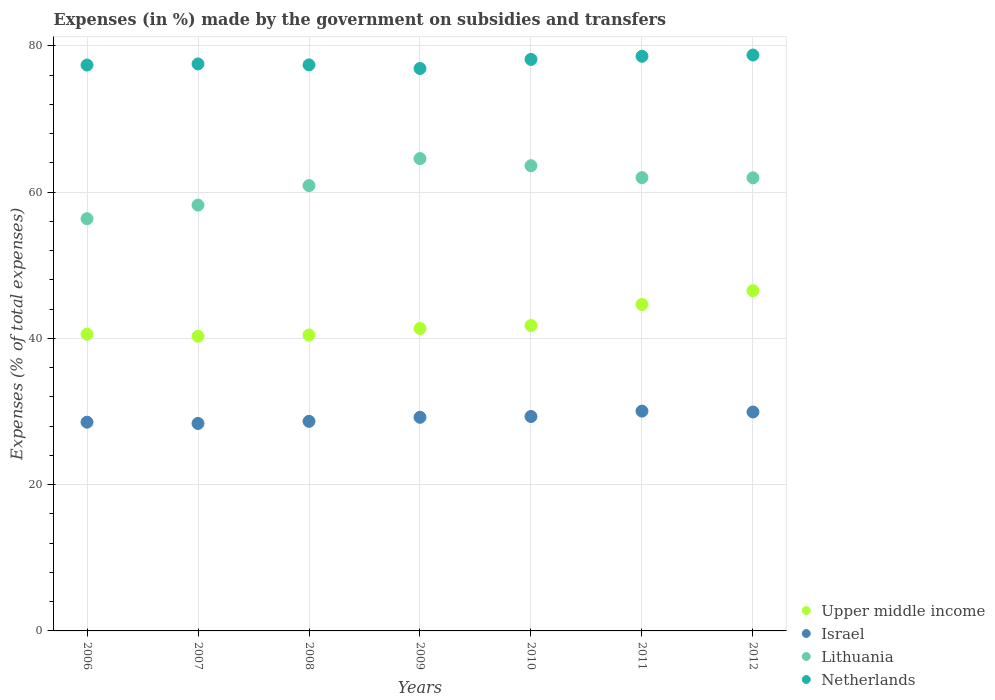What is the percentage of expenses made by the government on subsidies and transfers in Israel in 2008?
Provide a short and direct response. 28.66. Across all years, what is the maximum percentage of expenses made by the government on subsidies and transfers in Netherlands?
Make the answer very short. 78.76. Across all years, what is the minimum percentage of expenses made by the government on subsidies and transfers in Netherlands?
Make the answer very short. 76.91. What is the total percentage of expenses made by the government on subsidies and transfers in Upper middle income in the graph?
Provide a short and direct response. 295.63. What is the difference between the percentage of expenses made by the government on subsidies and transfers in Upper middle income in 2008 and that in 2010?
Keep it short and to the point. -1.3. What is the difference between the percentage of expenses made by the government on subsidies and transfers in Israel in 2009 and the percentage of expenses made by the government on subsidies and transfers in Netherlands in 2007?
Your response must be concise. -48.32. What is the average percentage of expenses made by the government on subsidies and transfers in Netherlands per year?
Offer a terse response. 77.82. In the year 2009, what is the difference between the percentage of expenses made by the government on subsidies and transfers in Netherlands and percentage of expenses made by the government on subsidies and transfers in Upper middle income?
Keep it short and to the point. 35.56. In how many years, is the percentage of expenses made by the government on subsidies and transfers in Upper middle income greater than 44 %?
Make the answer very short. 2. What is the ratio of the percentage of expenses made by the government on subsidies and transfers in Israel in 2008 to that in 2009?
Your answer should be compact. 0.98. Is the percentage of expenses made by the government on subsidies and transfers in Israel in 2008 less than that in 2010?
Make the answer very short. Yes. What is the difference between the highest and the second highest percentage of expenses made by the government on subsidies and transfers in Upper middle income?
Your response must be concise. 1.89. What is the difference between the highest and the lowest percentage of expenses made by the government on subsidies and transfers in Lithuania?
Your answer should be compact. 8.22. In how many years, is the percentage of expenses made by the government on subsidies and transfers in Israel greater than the average percentage of expenses made by the government on subsidies and transfers in Israel taken over all years?
Provide a short and direct response. 4. Is it the case that in every year, the sum of the percentage of expenses made by the government on subsidies and transfers in Netherlands and percentage of expenses made by the government on subsidies and transfers in Lithuania  is greater than the sum of percentage of expenses made by the government on subsidies and transfers in Israel and percentage of expenses made by the government on subsidies and transfers in Upper middle income?
Your answer should be very brief. Yes. Is the percentage of expenses made by the government on subsidies and transfers in Lithuania strictly greater than the percentage of expenses made by the government on subsidies and transfers in Netherlands over the years?
Give a very brief answer. No. How many dotlines are there?
Offer a terse response. 4. Are the values on the major ticks of Y-axis written in scientific E-notation?
Keep it short and to the point. No. Does the graph contain grids?
Keep it short and to the point. Yes. How are the legend labels stacked?
Your response must be concise. Vertical. What is the title of the graph?
Offer a terse response. Expenses (in %) made by the government on subsidies and transfers. Does "Guam" appear as one of the legend labels in the graph?
Provide a succinct answer. No. What is the label or title of the Y-axis?
Your answer should be very brief. Expenses (% of total expenses). What is the Expenses (% of total expenses) of Upper middle income in 2006?
Ensure brevity in your answer.  40.58. What is the Expenses (% of total expenses) in Israel in 2006?
Give a very brief answer. 28.55. What is the Expenses (% of total expenses) in Lithuania in 2006?
Ensure brevity in your answer.  56.37. What is the Expenses (% of total expenses) of Netherlands in 2006?
Offer a terse response. 77.38. What is the Expenses (% of total expenses) of Upper middle income in 2007?
Offer a terse response. 40.3. What is the Expenses (% of total expenses) in Israel in 2007?
Ensure brevity in your answer.  28.37. What is the Expenses (% of total expenses) in Lithuania in 2007?
Ensure brevity in your answer.  58.23. What is the Expenses (% of total expenses) in Netherlands in 2007?
Your answer should be compact. 77.54. What is the Expenses (% of total expenses) in Upper middle income in 2008?
Offer a very short reply. 40.47. What is the Expenses (% of total expenses) of Israel in 2008?
Offer a terse response. 28.66. What is the Expenses (% of total expenses) in Lithuania in 2008?
Your response must be concise. 60.9. What is the Expenses (% of total expenses) in Netherlands in 2008?
Your response must be concise. 77.41. What is the Expenses (% of total expenses) of Upper middle income in 2009?
Provide a short and direct response. 41.36. What is the Expenses (% of total expenses) of Israel in 2009?
Ensure brevity in your answer.  29.21. What is the Expenses (% of total expenses) of Lithuania in 2009?
Your response must be concise. 64.59. What is the Expenses (% of total expenses) in Netherlands in 2009?
Your answer should be very brief. 76.91. What is the Expenses (% of total expenses) in Upper middle income in 2010?
Keep it short and to the point. 41.76. What is the Expenses (% of total expenses) in Israel in 2010?
Give a very brief answer. 29.32. What is the Expenses (% of total expenses) in Lithuania in 2010?
Provide a succinct answer. 63.62. What is the Expenses (% of total expenses) of Netherlands in 2010?
Your response must be concise. 78.16. What is the Expenses (% of total expenses) of Upper middle income in 2011?
Give a very brief answer. 44.64. What is the Expenses (% of total expenses) in Israel in 2011?
Ensure brevity in your answer.  30.06. What is the Expenses (% of total expenses) in Lithuania in 2011?
Provide a succinct answer. 61.99. What is the Expenses (% of total expenses) in Netherlands in 2011?
Your answer should be compact. 78.58. What is the Expenses (% of total expenses) in Upper middle income in 2012?
Offer a very short reply. 46.53. What is the Expenses (% of total expenses) in Israel in 2012?
Keep it short and to the point. 29.94. What is the Expenses (% of total expenses) in Lithuania in 2012?
Offer a very short reply. 61.96. What is the Expenses (% of total expenses) in Netherlands in 2012?
Make the answer very short. 78.76. Across all years, what is the maximum Expenses (% of total expenses) in Upper middle income?
Offer a terse response. 46.53. Across all years, what is the maximum Expenses (% of total expenses) in Israel?
Offer a very short reply. 30.06. Across all years, what is the maximum Expenses (% of total expenses) of Lithuania?
Ensure brevity in your answer.  64.59. Across all years, what is the maximum Expenses (% of total expenses) in Netherlands?
Provide a succinct answer. 78.76. Across all years, what is the minimum Expenses (% of total expenses) in Upper middle income?
Your response must be concise. 40.3. Across all years, what is the minimum Expenses (% of total expenses) of Israel?
Your answer should be very brief. 28.37. Across all years, what is the minimum Expenses (% of total expenses) in Lithuania?
Make the answer very short. 56.37. Across all years, what is the minimum Expenses (% of total expenses) in Netherlands?
Give a very brief answer. 76.91. What is the total Expenses (% of total expenses) in Upper middle income in the graph?
Give a very brief answer. 295.63. What is the total Expenses (% of total expenses) in Israel in the graph?
Your answer should be compact. 204.11. What is the total Expenses (% of total expenses) of Lithuania in the graph?
Keep it short and to the point. 427.66. What is the total Expenses (% of total expenses) in Netherlands in the graph?
Ensure brevity in your answer.  544.74. What is the difference between the Expenses (% of total expenses) of Upper middle income in 2006 and that in 2007?
Provide a succinct answer. 0.28. What is the difference between the Expenses (% of total expenses) in Israel in 2006 and that in 2007?
Offer a very short reply. 0.17. What is the difference between the Expenses (% of total expenses) in Lithuania in 2006 and that in 2007?
Keep it short and to the point. -1.86. What is the difference between the Expenses (% of total expenses) of Netherlands in 2006 and that in 2007?
Keep it short and to the point. -0.15. What is the difference between the Expenses (% of total expenses) of Upper middle income in 2006 and that in 2008?
Provide a short and direct response. 0.11. What is the difference between the Expenses (% of total expenses) of Israel in 2006 and that in 2008?
Your answer should be compact. -0.11. What is the difference between the Expenses (% of total expenses) in Lithuania in 2006 and that in 2008?
Offer a terse response. -4.53. What is the difference between the Expenses (% of total expenses) in Netherlands in 2006 and that in 2008?
Give a very brief answer. -0.02. What is the difference between the Expenses (% of total expenses) of Upper middle income in 2006 and that in 2009?
Ensure brevity in your answer.  -0.78. What is the difference between the Expenses (% of total expenses) in Israel in 2006 and that in 2009?
Offer a very short reply. -0.67. What is the difference between the Expenses (% of total expenses) in Lithuania in 2006 and that in 2009?
Make the answer very short. -8.22. What is the difference between the Expenses (% of total expenses) in Netherlands in 2006 and that in 2009?
Give a very brief answer. 0.47. What is the difference between the Expenses (% of total expenses) of Upper middle income in 2006 and that in 2010?
Make the answer very short. -1.19. What is the difference between the Expenses (% of total expenses) of Israel in 2006 and that in 2010?
Make the answer very short. -0.78. What is the difference between the Expenses (% of total expenses) of Lithuania in 2006 and that in 2010?
Make the answer very short. -7.25. What is the difference between the Expenses (% of total expenses) in Netherlands in 2006 and that in 2010?
Your answer should be compact. -0.77. What is the difference between the Expenses (% of total expenses) in Upper middle income in 2006 and that in 2011?
Your answer should be compact. -4.06. What is the difference between the Expenses (% of total expenses) of Israel in 2006 and that in 2011?
Give a very brief answer. -1.51. What is the difference between the Expenses (% of total expenses) of Lithuania in 2006 and that in 2011?
Your answer should be compact. -5.62. What is the difference between the Expenses (% of total expenses) of Netherlands in 2006 and that in 2011?
Your response must be concise. -1.2. What is the difference between the Expenses (% of total expenses) in Upper middle income in 2006 and that in 2012?
Make the answer very short. -5.95. What is the difference between the Expenses (% of total expenses) in Israel in 2006 and that in 2012?
Your response must be concise. -1.39. What is the difference between the Expenses (% of total expenses) of Lithuania in 2006 and that in 2012?
Ensure brevity in your answer.  -5.59. What is the difference between the Expenses (% of total expenses) of Netherlands in 2006 and that in 2012?
Make the answer very short. -1.37. What is the difference between the Expenses (% of total expenses) of Upper middle income in 2007 and that in 2008?
Your answer should be compact. -0.17. What is the difference between the Expenses (% of total expenses) of Israel in 2007 and that in 2008?
Make the answer very short. -0.29. What is the difference between the Expenses (% of total expenses) of Lithuania in 2007 and that in 2008?
Your answer should be very brief. -2.67. What is the difference between the Expenses (% of total expenses) in Netherlands in 2007 and that in 2008?
Your response must be concise. 0.13. What is the difference between the Expenses (% of total expenses) of Upper middle income in 2007 and that in 2009?
Ensure brevity in your answer.  -1.06. What is the difference between the Expenses (% of total expenses) of Israel in 2007 and that in 2009?
Keep it short and to the point. -0.84. What is the difference between the Expenses (% of total expenses) of Lithuania in 2007 and that in 2009?
Provide a short and direct response. -6.36. What is the difference between the Expenses (% of total expenses) in Netherlands in 2007 and that in 2009?
Keep it short and to the point. 0.63. What is the difference between the Expenses (% of total expenses) in Upper middle income in 2007 and that in 2010?
Make the answer very short. -1.47. What is the difference between the Expenses (% of total expenses) of Israel in 2007 and that in 2010?
Your response must be concise. -0.95. What is the difference between the Expenses (% of total expenses) of Lithuania in 2007 and that in 2010?
Offer a very short reply. -5.38. What is the difference between the Expenses (% of total expenses) in Netherlands in 2007 and that in 2010?
Ensure brevity in your answer.  -0.62. What is the difference between the Expenses (% of total expenses) of Upper middle income in 2007 and that in 2011?
Your answer should be very brief. -4.34. What is the difference between the Expenses (% of total expenses) of Israel in 2007 and that in 2011?
Your response must be concise. -1.68. What is the difference between the Expenses (% of total expenses) in Lithuania in 2007 and that in 2011?
Give a very brief answer. -3.75. What is the difference between the Expenses (% of total expenses) of Netherlands in 2007 and that in 2011?
Offer a terse response. -1.05. What is the difference between the Expenses (% of total expenses) of Upper middle income in 2007 and that in 2012?
Your response must be concise. -6.23. What is the difference between the Expenses (% of total expenses) in Israel in 2007 and that in 2012?
Your answer should be compact. -1.57. What is the difference between the Expenses (% of total expenses) of Lithuania in 2007 and that in 2012?
Offer a terse response. -3.73. What is the difference between the Expenses (% of total expenses) in Netherlands in 2007 and that in 2012?
Your response must be concise. -1.22. What is the difference between the Expenses (% of total expenses) in Upper middle income in 2008 and that in 2009?
Your answer should be compact. -0.89. What is the difference between the Expenses (% of total expenses) in Israel in 2008 and that in 2009?
Offer a very short reply. -0.56. What is the difference between the Expenses (% of total expenses) in Lithuania in 2008 and that in 2009?
Offer a very short reply. -3.69. What is the difference between the Expenses (% of total expenses) in Netherlands in 2008 and that in 2009?
Make the answer very short. 0.49. What is the difference between the Expenses (% of total expenses) in Upper middle income in 2008 and that in 2010?
Offer a terse response. -1.3. What is the difference between the Expenses (% of total expenses) in Israel in 2008 and that in 2010?
Your response must be concise. -0.66. What is the difference between the Expenses (% of total expenses) of Lithuania in 2008 and that in 2010?
Your answer should be very brief. -2.72. What is the difference between the Expenses (% of total expenses) of Netherlands in 2008 and that in 2010?
Ensure brevity in your answer.  -0.75. What is the difference between the Expenses (% of total expenses) of Upper middle income in 2008 and that in 2011?
Keep it short and to the point. -4.17. What is the difference between the Expenses (% of total expenses) of Israel in 2008 and that in 2011?
Provide a short and direct response. -1.4. What is the difference between the Expenses (% of total expenses) of Lithuania in 2008 and that in 2011?
Provide a succinct answer. -1.09. What is the difference between the Expenses (% of total expenses) of Netherlands in 2008 and that in 2011?
Give a very brief answer. -1.18. What is the difference between the Expenses (% of total expenses) in Upper middle income in 2008 and that in 2012?
Your answer should be very brief. -6.06. What is the difference between the Expenses (% of total expenses) of Israel in 2008 and that in 2012?
Your response must be concise. -1.28. What is the difference between the Expenses (% of total expenses) of Lithuania in 2008 and that in 2012?
Provide a short and direct response. -1.06. What is the difference between the Expenses (% of total expenses) in Netherlands in 2008 and that in 2012?
Offer a very short reply. -1.35. What is the difference between the Expenses (% of total expenses) in Upper middle income in 2009 and that in 2010?
Your response must be concise. -0.41. What is the difference between the Expenses (% of total expenses) of Israel in 2009 and that in 2010?
Provide a succinct answer. -0.11. What is the difference between the Expenses (% of total expenses) of Lithuania in 2009 and that in 2010?
Give a very brief answer. 0.98. What is the difference between the Expenses (% of total expenses) of Netherlands in 2009 and that in 2010?
Make the answer very short. -1.24. What is the difference between the Expenses (% of total expenses) of Upper middle income in 2009 and that in 2011?
Your answer should be compact. -3.28. What is the difference between the Expenses (% of total expenses) of Israel in 2009 and that in 2011?
Keep it short and to the point. -0.84. What is the difference between the Expenses (% of total expenses) in Lithuania in 2009 and that in 2011?
Provide a short and direct response. 2.61. What is the difference between the Expenses (% of total expenses) of Netherlands in 2009 and that in 2011?
Your answer should be very brief. -1.67. What is the difference between the Expenses (% of total expenses) in Upper middle income in 2009 and that in 2012?
Your response must be concise. -5.17. What is the difference between the Expenses (% of total expenses) of Israel in 2009 and that in 2012?
Make the answer very short. -0.73. What is the difference between the Expenses (% of total expenses) of Lithuania in 2009 and that in 2012?
Offer a terse response. 2.63. What is the difference between the Expenses (% of total expenses) of Netherlands in 2009 and that in 2012?
Your response must be concise. -1.84. What is the difference between the Expenses (% of total expenses) in Upper middle income in 2010 and that in 2011?
Your response must be concise. -2.88. What is the difference between the Expenses (% of total expenses) of Israel in 2010 and that in 2011?
Your answer should be compact. -0.73. What is the difference between the Expenses (% of total expenses) in Lithuania in 2010 and that in 2011?
Make the answer very short. 1.63. What is the difference between the Expenses (% of total expenses) of Netherlands in 2010 and that in 2011?
Provide a short and direct response. -0.43. What is the difference between the Expenses (% of total expenses) of Upper middle income in 2010 and that in 2012?
Make the answer very short. -4.76. What is the difference between the Expenses (% of total expenses) in Israel in 2010 and that in 2012?
Your answer should be very brief. -0.62. What is the difference between the Expenses (% of total expenses) in Lithuania in 2010 and that in 2012?
Ensure brevity in your answer.  1.66. What is the difference between the Expenses (% of total expenses) in Netherlands in 2010 and that in 2012?
Provide a succinct answer. -0.6. What is the difference between the Expenses (% of total expenses) of Upper middle income in 2011 and that in 2012?
Ensure brevity in your answer.  -1.89. What is the difference between the Expenses (% of total expenses) of Israel in 2011 and that in 2012?
Ensure brevity in your answer.  0.12. What is the difference between the Expenses (% of total expenses) of Lithuania in 2011 and that in 2012?
Offer a terse response. 0.03. What is the difference between the Expenses (% of total expenses) of Netherlands in 2011 and that in 2012?
Provide a succinct answer. -0.17. What is the difference between the Expenses (% of total expenses) of Upper middle income in 2006 and the Expenses (% of total expenses) of Israel in 2007?
Ensure brevity in your answer.  12.21. What is the difference between the Expenses (% of total expenses) in Upper middle income in 2006 and the Expenses (% of total expenses) in Lithuania in 2007?
Your response must be concise. -17.66. What is the difference between the Expenses (% of total expenses) in Upper middle income in 2006 and the Expenses (% of total expenses) in Netherlands in 2007?
Give a very brief answer. -36.96. What is the difference between the Expenses (% of total expenses) in Israel in 2006 and the Expenses (% of total expenses) in Lithuania in 2007?
Make the answer very short. -29.69. What is the difference between the Expenses (% of total expenses) in Israel in 2006 and the Expenses (% of total expenses) in Netherlands in 2007?
Ensure brevity in your answer.  -48.99. What is the difference between the Expenses (% of total expenses) in Lithuania in 2006 and the Expenses (% of total expenses) in Netherlands in 2007?
Your answer should be compact. -21.17. What is the difference between the Expenses (% of total expenses) in Upper middle income in 2006 and the Expenses (% of total expenses) in Israel in 2008?
Provide a succinct answer. 11.92. What is the difference between the Expenses (% of total expenses) in Upper middle income in 2006 and the Expenses (% of total expenses) in Lithuania in 2008?
Offer a terse response. -20.32. What is the difference between the Expenses (% of total expenses) in Upper middle income in 2006 and the Expenses (% of total expenses) in Netherlands in 2008?
Offer a very short reply. -36.83. What is the difference between the Expenses (% of total expenses) in Israel in 2006 and the Expenses (% of total expenses) in Lithuania in 2008?
Offer a terse response. -32.35. What is the difference between the Expenses (% of total expenses) of Israel in 2006 and the Expenses (% of total expenses) of Netherlands in 2008?
Keep it short and to the point. -48.86. What is the difference between the Expenses (% of total expenses) in Lithuania in 2006 and the Expenses (% of total expenses) in Netherlands in 2008?
Your answer should be compact. -21.04. What is the difference between the Expenses (% of total expenses) of Upper middle income in 2006 and the Expenses (% of total expenses) of Israel in 2009?
Ensure brevity in your answer.  11.36. What is the difference between the Expenses (% of total expenses) in Upper middle income in 2006 and the Expenses (% of total expenses) in Lithuania in 2009?
Your answer should be compact. -24.02. What is the difference between the Expenses (% of total expenses) in Upper middle income in 2006 and the Expenses (% of total expenses) in Netherlands in 2009?
Your response must be concise. -36.34. What is the difference between the Expenses (% of total expenses) of Israel in 2006 and the Expenses (% of total expenses) of Lithuania in 2009?
Your answer should be very brief. -36.05. What is the difference between the Expenses (% of total expenses) of Israel in 2006 and the Expenses (% of total expenses) of Netherlands in 2009?
Your response must be concise. -48.37. What is the difference between the Expenses (% of total expenses) of Lithuania in 2006 and the Expenses (% of total expenses) of Netherlands in 2009?
Offer a terse response. -20.54. What is the difference between the Expenses (% of total expenses) of Upper middle income in 2006 and the Expenses (% of total expenses) of Israel in 2010?
Keep it short and to the point. 11.26. What is the difference between the Expenses (% of total expenses) of Upper middle income in 2006 and the Expenses (% of total expenses) of Lithuania in 2010?
Provide a succinct answer. -23.04. What is the difference between the Expenses (% of total expenses) in Upper middle income in 2006 and the Expenses (% of total expenses) in Netherlands in 2010?
Your answer should be very brief. -37.58. What is the difference between the Expenses (% of total expenses) of Israel in 2006 and the Expenses (% of total expenses) of Lithuania in 2010?
Give a very brief answer. -35.07. What is the difference between the Expenses (% of total expenses) of Israel in 2006 and the Expenses (% of total expenses) of Netherlands in 2010?
Provide a succinct answer. -49.61. What is the difference between the Expenses (% of total expenses) of Lithuania in 2006 and the Expenses (% of total expenses) of Netherlands in 2010?
Keep it short and to the point. -21.78. What is the difference between the Expenses (% of total expenses) of Upper middle income in 2006 and the Expenses (% of total expenses) of Israel in 2011?
Keep it short and to the point. 10.52. What is the difference between the Expenses (% of total expenses) in Upper middle income in 2006 and the Expenses (% of total expenses) in Lithuania in 2011?
Your answer should be compact. -21.41. What is the difference between the Expenses (% of total expenses) in Upper middle income in 2006 and the Expenses (% of total expenses) in Netherlands in 2011?
Give a very brief answer. -38.01. What is the difference between the Expenses (% of total expenses) in Israel in 2006 and the Expenses (% of total expenses) in Lithuania in 2011?
Make the answer very short. -33.44. What is the difference between the Expenses (% of total expenses) in Israel in 2006 and the Expenses (% of total expenses) in Netherlands in 2011?
Your answer should be very brief. -50.04. What is the difference between the Expenses (% of total expenses) of Lithuania in 2006 and the Expenses (% of total expenses) of Netherlands in 2011?
Offer a terse response. -22.21. What is the difference between the Expenses (% of total expenses) of Upper middle income in 2006 and the Expenses (% of total expenses) of Israel in 2012?
Keep it short and to the point. 10.64. What is the difference between the Expenses (% of total expenses) in Upper middle income in 2006 and the Expenses (% of total expenses) in Lithuania in 2012?
Ensure brevity in your answer.  -21.38. What is the difference between the Expenses (% of total expenses) of Upper middle income in 2006 and the Expenses (% of total expenses) of Netherlands in 2012?
Provide a short and direct response. -38.18. What is the difference between the Expenses (% of total expenses) of Israel in 2006 and the Expenses (% of total expenses) of Lithuania in 2012?
Provide a short and direct response. -33.41. What is the difference between the Expenses (% of total expenses) of Israel in 2006 and the Expenses (% of total expenses) of Netherlands in 2012?
Give a very brief answer. -50.21. What is the difference between the Expenses (% of total expenses) in Lithuania in 2006 and the Expenses (% of total expenses) in Netherlands in 2012?
Your answer should be very brief. -22.39. What is the difference between the Expenses (% of total expenses) in Upper middle income in 2007 and the Expenses (% of total expenses) in Israel in 2008?
Provide a short and direct response. 11.64. What is the difference between the Expenses (% of total expenses) of Upper middle income in 2007 and the Expenses (% of total expenses) of Lithuania in 2008?
Your answer should be compact. -20.6. What is the difference between the Expenses (% of total expenses) of Upper middle income in 2007 and the Expenses (% of total expenses) of Netherlands in 2008?
Provide a short and direct response. -37.11. What is the difference between the Expenses (% of total expenses) in Israel in 2007 and the Expenses (% of total expenses) in Lithuania in 2008?
Offer a terse response. -32.53. What is the difference between the Expenses (% of total expenses) in Israel in 2007 and the Expenses (% of total expenses) in Netherlands in 2008?
Keep it short and to the point. -49.04. What is the difference between the Expenses (% of total expenses) of Lithuania in 2007 and the Expenses (% of total expenses) of Netherlands in 2008?
Your answer should be very brief. -19.17. What is the difference between the Expenses (% of total expenses) of Upper middle income in 2007 and the Expenses (% of total expenses) of Israel in 2009?
Offer a terse response. 11.08. What is the difference between the Expenses (% of total expenses) in Upper middle income in 2007 and the Expenses (% of total expenses) in Lithuania in 2009?
Your answer should be compact. -24.3. What is the difference between the Expenses (% of total expenses) in Upper middle income in 2007 and the Expenses (% of total expenses) in Netherlands in 2009?
Provide a succinct answer. -36.62. What is the difference between the Expenses (% of total expenses) of Israel in 2007 and the Expenses (% of total expenses) of Lithuania in 2009?
Keep it short and to the point. -36.22. What is the difference between the Expenses (% of total expenses) in Israel in 2007 and the Expenses (% of total expenses) in Netherlands in 2009?
Your answer should be compact. -48.54. What is the difference between the Expenses (% of total expenses) in Lithuania in 2007 and the Expenses (% of total expenses) in Netherlands in 2009?
Provide a short and direct response. -18.68. What is the difference between the Expenses (% of total expenses) in Upper middle income in 2007 and the Expenses (% of total expenses) in Israel in 2010?
Offer a very short reply. 10.98. What is the difference between the Expenses (% of total expenses) in Upper middle income in 2007 and the Expenses (% of total expenses) in Lithuania in 2010?
Your response must be concise. -23.32. What is the difference between the Expenses (% of total expenses) in Upper middle income in 2007 and the Expenses (% of total expenses) in Netherlands in 2010?
Keep it short and to the point. -37.86. What is the difference between the Expenses (% of total expenses) of Israel in 2007 and the Expenses (% of total expenses) of Lithuania in 2010?
Provide a succinct answer. -35.25. What is the difference between the Expenses (% of total expenses) in Israel in 2007 and the Expenses (% of total expenses) in Netherlands in 2010?
Keep it short and to the point. -49.79. What is the difference between the Expenses (% of total expenses) in Lithuania in 2007 and the Expenses (% of total expenses) in Netherlands in 2010?
Keep it short and to the point. -19.92. What is the difference between the Expenses (% of total expenses) of Upper middle income in 2007 and the Expenses (% of total expenses) of Israel in 2011?
Provide a short and direct response. 10.24. What is the difference between the Expenses (% of total expenses) in Upper middle income in 2007 and the Expenses (% of total expenses) in Lithuania in 2011?
Offer a very short reply. -21.69. What is the difference between the Expenses (% of total expenses) of Upper middle income in 2007 and the Expenses (% of total expenses) of Netherlands in 2011?
Provide a succinct answer. -38.29. What is the difference between the Expenses (% of total expenses) of Israel in 2007 and the Expenses (% of total expenses) of Lithuania in 2011?
Provide a succinct answer. -33.62. What is the difference between the Expenses (% of total expenses) in Israel in 2007 and the Expenses (% of total expenses) in Netherlands in 2011?
Your answer should be very brief. -50.21. What is the difference between the Expenses (% of total expenses) in Lithuania in 2007 and the Expenses (% of total expenses) in Netherlands in 2011?
Provide a short and direct response. -20.35. What is the difference between the Expenses (% of total expenses) in Upper middle income in 2007 and the Expenses (% of total expenses) in Israel in 2012?
Make the answer very short. 10.36. What is the difference between the Expenses (% of total expenses) of Upper middle income in 2007 and the Expenses (% of total expenses) of Lithuania in 2012?
Offer a terse response. -21.66. What is the difference between the Expenses (% of total expenses) of Upper middle income in 2007 and the Expenses (% of total expenses) of Netherlands in 2012?
Make the answer very short. -38.46. What is the difference between the Expenses (% of total expenses) of Israel in 2007 and the Expenses (% of total expenses) of Lithuania in 2012?
Your answer should be very brief. -33.59. What is the difference between the Expenses (% of total expenses) of Israel in 2007 and the Expenses (% of total expenses) of Netherlands in 2012?
Ensure brevity in your answer.  -50.39. What is the difference between the Expenses (% of total expenses) of Lithuania in 2007 and the Expenses (% of total expenses) of Netherlands in 2012?
Provide a short and direct response. -20.52. What is the difference between the Expenses (% of total expenses) of Upper middle income in 2008 and the Expenses (% of total expenses) of Israel in 2009?
Your response must be concise. 11.25. What is the difference between the Expenses (% of total expenses) in Upper middle income in 2008 and the Expenses (% of total expenses) in Lithuania in 2009?
Your answer should be compact. -24.13. What is the difference between the Expenses (% of total expenses) of Upper middle income in 2008 and the Expenses (% of total expenses) of Netherlands in 2009?
Provide a short and direct response. -36.45. What is the difference between the Expenses (% of total expenses) in Israel in 2008 and the Expenses (% of total expenses) in Lithuania in 2009?
Provide a succinct answer. -35.94. What is the difference between the Expenses (% of total expenses) of Israel in 2008 and the Expenses (% of total expenses) of Netherlands in 2009?
Your response must be concise. -48.25. What is the difference between the Expenses (% of total expenses) of Lithuania in 2008 and the Expenses (% of total expenses) of Netherlands in 2009?
Your answer should be compact. -16.01. What is the difference between the Expenses (% of total expenses) of Upper middle income in 2008 and the Expenses (% of total expenses) of Israel in 2010?
Your answer should be compact. 11.14. What is the difference between the Expenses (% of total expenses) of Upper middle income in 2008 and the Expenses (% of total expenses) of Lithuania in 2010?
Provide a succinct answer. -23.15. What is the difference between the Expenses (% of total expenses) of Upper middle income in 2008 and the Expenses (% of total expenses) of Netherlands in 2010?
Your answer should be very brief. -37.69. What is the difference between the Expenses (% of total expenses) in Israel in 2008 and the Expenses (% of total expenses) in Lithuania in 2010?
Provide a short and direct response. -34.96. What is the difference between the Expenses (% of total expenses) of Israel in 2008 and the Expenses (% of total expenses) of Netherlands in 2010?
Keep it short and to the point. -49.5. What is the difference between the Expenses (% of total expenses) of Lithuania in 2008 and the Expenses (% of total expenses) of Netherlands in 2010?
Your response must be concise. -17.26. What is the difference between the Expenses (% of total expenses) in Upper middle income in 2008 and the Expenses (% of total expenses) in Israel in 2011?
Your answer should be very brief. 10.41. What is the difference between the Expenses (% of total expenses) of Upper middle income in 2008 and the Expenses (% of total expenses) of Lithuania in 2011?
Give a very brief answer. -21.52. What is the difference between the Expenses (% of total expenses) of Upper middle income in 2008 and the Expenses (% of total expenses) of Netherlands in 2011?
Your response must be concise. -38.12. What is the difference between the Expenses (% of total expenses) in Israel in 2008 and the Expenses (% of total expenses) in Lithuania in 2011?
Provide a short and direct response. -33.33. What is the difference between the Expenses (% of total expenses) in Israel in 2008 and the Expenses (% of total expenses) in Netherlands in 2011?
Provide a short and direct response. -49.93. What is the difference between the Expenses (% of total expenses) of Lithuania in 2008 and the Expenses (% of total expenses) of Netherlands in 2011?
Offer a terse response. -17.68. What is the difference between the Expenses (% of total expenses) of Upper middle income in 2008 and the Expenses (% of total expenses) of Israel in 2012?
Your answer should be compact. 10.53. What is the difference between the Expenses (% of total expenses) in Upper middle income in 2008 and the Expenses (% of total expenses) in Lithuania in 2012?
Keep it short and to the point. -21.49. What is the difference between the Expenses (% of total expenses) of Upper middle income in 2008 and the Expenses (% of total expenses) of Netherlands in 2012?
Provide a succinct answer. -38.29. What is the difference between the Expenses (% of total expenses) in Israel in 2008 and the Expenses (% of total expenses) in Lithuania in 2012?
Ensure brevity in your answer.  -33.3. What is the difference between the Expenses (% of total expenses) of Israel in 2008 and the Expenses (% of total expenses) of Netherlands in 2012?
Offer a very short reply. -50.1. What is the difference between the Expenses (% of total expenses) of Lithuania in 2008 and the Expenses (% of total expenses) of Netherlands in 2012?
Ensure brevity in your answer.  -17.86. What is the difference between the Expenses (% of total expenses) in Upper middle income in 2009 and the Expenses (% of total expenses) in Israel in 2010?
Ensure brevity in your answer.  12.03. What is the difference between the Expenses (% of total expenses) of Upper middle income in 2009 and the Expenses (% of total expenses) of Lithuania in 2010?
Give a very brief answer. -22.26. What is the difference between the Expenses (% of total expenses) in Upper middle income in 2009 and the Expenses (% of total expenses) in Netherlands in 2010?
Make the answer very short. -36.8. What is the difference between the Expenses (% of total expenses) in Israel in 2009 and the Expenses (% of total expenses) in Lithuania in 2010?
Offer a very short reply. -34.4. What is the difference between the Expenses (% of total expenses) in Israel in 2009 and the Expenses (% of total expenses) in Netherlands in 2010?
Your answer should be very brief. -48.94. What is the difference between the Expenses (% of total expenses) of Lithuania in 2009 and the Expenses (% of total expenses) of Netherlands in 2010?
Your response must be concise. -13.56. What is the difference between the Expenses (% of total expenses) of Upper middle income in 2009 and the Expenses (% of total expenses) of Israel in 2011?
Offer a very short reply. 11.3. What is the difference between the Expenses (% of total expenses) of Upper middle income in 2009 and the Expenses (% of total expenses) of Lithuania in 2011?
Your answer should be compact. -20.63. What is the difference between the Expenses (% of total expenses) in Upper middle income in 2009 and the Expenses (% of total expenses) in Netherlands in 2011?
Provide a short and direct response. -37.23. What is the difference between the Expenses (% of total expenses) of Israel in 2009 and the Expenses (% of total expenses) of Lithuania in 2011?
Your answer should be compact. -32.77. What is the difference between the Expenses (% of total expenses) of Israel in 2009 and the Expenses (% of total expenses) of Netherlands in 2011?
Make the answer very short. -49.37. What is the difference between the Expenses (% of total expenses) of Lithuania in 2009 and the Expenses (% of total expenses) of Netherlands in 2011?
Provide a short and direct response. -13.99. What is the difference between the Expenses (% of total expenses) of Upper middle income in 2009 and the Expenses (% of total expenses) of Israel in 2012?
Your answer should be compact. 11.42. What is the difference between the Expenses (% of total expenses) in Upper middle income in 2009 and the Expenses (% of total expenses) in Lithuania in 2012?
Offer a very short reply. -20.6. What is the difference between the Expenses (% of total expenses) in Upper middle income in 2009 and the Expenses (% of total expenses) in Netherlands in 2012?
Make the answer very short. -37.4. What is the difference between the Expenses (% of total expenses) of Israel in 2009 and the Expenses (% of total expenses) of Lithuania in 2012?
Ensure brevity in your answer.  -32.75. What is the difference between the Expenses (% of total expenses) in Israel in 2009 and the Expenses (% of total expenses) in Netherlands in 2012?
Make the answer very short. -49.54. What is the difference between the Expenses (% of total expenses) in Lithuania in 2009 and the Expenses (% of total expenses) in Netherlands in 2012?
Offer a terse response. -14.16. What is the difference between the Expenses (% of total expenses) in Upper middle income in 2010 and the Expenses (% of total expenses) in Israel in 2011?
Offer a terse response. 11.71. What is the difference between the Expenses (% of total expenses) in Upper middle income in 2010 and the Expenses (% of total expenses) in Lithuania in 2011?
Provide a succinct answer. -20.22. What is the difference between the Expenses (% of total expenses) of Upper middle income in 2010 and the Expenses (% of total expenses) of Netherlands in 2011?
Offer a terse response. -36.82. What is the difference between the Expenses (% of total expenses) in Israel in 2010 and the Expenses (% of total expenses) in Lithuania in 2011?
Your response must be concise. -32.67. What is the difference between the Expenses (% of total expenses) of Israel in 2010 and the Expenses (% of total expenses) of Netherlands in 2011?
Your response must be concise. -49.26. What is the difference between the Expenses (% of total expenses) of Lithuania in 2010 and the Expenses (% of total expenses) of Netherlands in 2011?
Provide a succinct answer. -14.97. What is the difference between the Expenses (% of total expenses) of Upper middle income in 2010 and the Expenses (% of total expenses) of Israel in 2012?
Offer a very short reply. 11.82. What is the difference between the Expenses (% of total expenses) in Upper middle income in 2010 and the Expenses (% of total expenses) in Lithuania in 2012?
Keep it short and to the point. -20.2. What is the difference between the Expenses (% of total expenses) in Upper middle income in 2010 and the Expenses (% of total expenses) in Netherlands in 2012?
Your response must be concise. -36.99. What is the difference between the Expenses (% of total expenses) in Israel in 2010 and the Expenses (% of total expenses) in Lithuania in 2012?
Offer a very short reply. -32.64. What is the difference between the Expenses (% of total expenses) in Israel in 2010 and the Expenses (% of total expenses) in Netherlands in 2012?
Ensure brevity in your answer.  -49.44. What is the difference between the Expenses (% of total expenses) of Lithuania in 2010 and the Expenses (% of total expenses) of Netherlands in 2012?
Make the answer very short. -15.14. What is the difference between the Expenses (% of total expenses) of Upper middle income in 2011 and the Expenses (% of total expenses) of Israel in 2012?
Offer a terse response. 14.7. What is the difference between the Expenses (% of total expenses) in Upper middle income in 2011 and the Expenses (% of total expenses) in Lithuania in 2012?
Give a very brief answer. -17.32. What is the difference between the Expenses (% of total expenses) in Upper middle income in 2011 and the Expenses (% of total expenses) in Netherlands in 2012?
Keep it short and to the point. -34.12. What is the difference between the Expenses (% of total expenses) in Israel in 2011 and the Expenses (% of total expenses) in Lithuania in 2012?
Provide a short and direct response. -31.9. What is the difference between the Expenses (% of total expenses) in Israel in 2011 and the Expenses (% of total expenses) in Netherlands in 2012?
Give a very brief answer. -48.7. What is the difference between the Expenses (% of total expenses) of Lithuania in 2011 and the Expenses (% of total expenses) of Netherlands in 2012?
Ensure brevity in your answer.  -16.77. What is the average Expenses (% of total expenses) in Upper middle income per year?
Offer a very short reply. 42.23. What is the average Expenses (% of total expenses) in Israel per year?
Make the answer very short. 29.16. What is the average Expenses (% of total expenses) in Lithuania per year?
Offer a terse response. 61.09. What is the average Expenses (% of total expenses) of Netherlands per year?
Your answer should be very brief. 77.82. In the year 2006, what is the difference between the Expenses (% of total expenses) of Upper middle income and Expenses (% of total expenses) of Israel?
Give a very brief answer. 12.03. In the year 2006, what is the difference between the Expenses (% of total expenses) of Upper middle income and Expenses (% of total expenses) of Lithuania?
Ensure brevity in your answer.  -15.79. In the year 2006, what is the difference between the Expenses (% of total expenses) of Upper middle income and Expenses (% of total expenses) of Netherlands?
Provide a short and direct response. -36.81. In the year 2006, what is the difference between the Expenses (% of total expenses) of Israel and Expenses (% of total expenses) of Lithuania?
Ensure brevity in your answer.  -27.83. In the year 2006, what is the difference between the Expenses (% of total expenses) in Israel and Expenses (% of total expenses) in Netherlands?
Ensure brevity in your answer.  -48.84. In the year 2006, what is the difference between the Expenses (% of total expenses) in Lithuania and Expenses (% of total expenses) in Netherlands?
Provide a succinct answer. -21.01. In the year 2007, what is the difference between the Expenses (% of total expenses) of Upper middle income and Expenses (% of total expenses) of Israel?
Give a very brief answer. 11.93. In the year 2007, what is the difference between the Expenses (% of total expenses) in Upper middle income and Expenses (% of total expenses) in Lithuania?
Your response must be concise. -17.94. In the year 2007, what is the difference between the Expenses (% of total expenses) of Upper middle income and Expenses (% of total expenses) of Netherlands?
Offer a terse response. -37.24. In the year 2007, what is the difference between the Expenses (% of total expenses) in Israel and Expenses (% of total expenses) in Lithuania?
Offer a very short reply. -29.86. In the year 2007, what is the difference between the Expenses (% of total expenses) of Israel and Expenses (% of total expenses) of Netherlands?
Provide a succinct answer. -49.17. In the year 2007, what is the difference between the Expenses (% of total expenses) in Lithuania and Expenses (% of total expenses) in Netherlands?
Make the answer very short. -19.3. In the year 2008, what is the difference between the Expenses (% of total expenses) of Upper middle income and Expenses (% of total expenses) of Israel?
Give a very brief answer. 11.81. In the year 2008, what is the difference between the Expenses (% of total expenses) of Upper middle income and Expenses (% of total expenses) of Lithuania?
Your response must be concise. -20.43. In the year 2008, what is the difference between the Expenses (% of total expenses) of Upper middle income and Expenses (% of total expenses) of Netherlands?
Keep it short and to the point. -36.94. In the year 2008, what is the difference between the Expenses (% of total expenses) of Israel and Expenses (% of total expenses) of Lithuania?
Ensure brevity in your answer.  -32.24. In the year 2008, what is the difference between the Expenses (% of total expenses) of Israel and Expenses (% of total expenses) of Netherlands?
Give a very brief answer. -48.75. In the year 2008, what is the difference between the Expenses (% of total expenses) of Lithuania and Expenses (% of total expenses) of Netherlands?
Ensure brevity in your answer.  -16.51. In the year 2009, what is the difference between the Expenses (% of total expenses) of Upper middle income and Expenses (% of total expenses) of Israel?
Offer a terse response. 12.14. In the year 2009, what is the difference between the Expenses (% of total expenses) of Upper middle income and Expenses (% of total expenses) of Lithuania?
Ensure brevity in your answer.  -23.24. In the year 2009, what is the difference between the Expenses (% of total expenses) in Upper middle income and Expenses (% of total expenses) in Netherlands?
Provide a short and direct response. -35.56. In the year 2009, what is the difference between the Expenses (% of total expenses) in Israel and Expenses (% of total expenses) in Lithuania?
Provide a short and direct response. -35.38. In the year 2009, what is the difference between the Expenses (% of total expenses) of Israel and Expenses (% of total expenses) of Netherlands?
Your answer should be compact. -47.7. In the year 2009, what is the difference between the Expenses (% of total expenses) in Lithuania and Expenses (% of total expenses) in Netherlands?
Your answer should be compact. -12.32. In the year 2010, what is the difference between the Expenses (% of total expenses) of Upper middle income and Expenses (% of total expenses) of Israel?
Ensure brevity in your answer.  12.44. In the year 2010, what is the difference between the Expenses (% of total expenses) in Upper middle income and Expenses (% of total expenses) in Lithuania?
Offer a terse response. -21.85. In the year 2010, what is the difference between the Expenses (% of total expenses) of Upper middle income and Expenses (% of total expenses) of Netherlands?
Give a very brief answer. -36.39. In the year 2010, what is the difference between the Expenses (% of total expenses) in Israel and Expenses (% of total expenses) in Lithuania?
Provide a short and direct response. -34.3. In the year 2010, what is the difference between the Expenses (% of total expenses) of Israel and Expenses (% of total expenses) of Netherlands?
Provide a succinct answer. -48.83. In the year 2010, what is the difference between the Expenses (% of total expenses) of Lithuania and Expenses (% of total expenses) of Netherlands?
Keep it short and to the point. -14.54. In the year 2011, what is the difference between the Expenses (% of total expenses) of Upper middle income and Expenses (% of total expenses) of Israel?
Offer a terse response. 14.59. In the year 2011, what is the difference between the Expenses (% of total expenses) in Upper middle income and Expenses (% of total expenses) in Lithuania?
Offer a terse response. -17.35. In the year 2011, what is the difference between the Expenses (% of total expenses) of Upper middle income and Expenses (% of total expenses) of Netherlands?
Ensure brevity in your answer.  -33.94. In the year 2011, what is the difference between the Expenses (% of total expenses) of Israel and Expenses (% of total expenses) of Lithuania?
Offer a terse response. -31.93. In the year 2011, what is the difference between the Expenses (% of total expenses) of Israel and Expenses (% of total expenses) of Netherlands?
Give a very brief answer. -48.53. In the year 2011, what is the difference between the Expenses (% of total expenses) of Lithuania and Expenses (% of total expenses) of Netherlands?
Give a very brief answer. -16.6. In the year 2012, what is the difference between the Expenses (% of total expenses) of Upper middle income and Expenses (% of total expenses) of Israel?
Make the answer very short. 16.59. In the year 2012, what is the difference between the Expenses (% of total expenses) in Upper middle income and Expenses (% of total expenses) in Lithuania?
Make the answer very short. -15.43. In the year 2012, what is the difference between the Expenses (% of total expenses) in Upper middle income and Expenses (% of total expenses) in Netherlands?
Your answer should be very brief. -32.23. In the year 2012, what is the difference between the Expenses (% of total expenses) in Israel and Expenses (% of total expenses) in Lithuania?
Ensure brevity in your answer.  -32.02. In the year 2012, what is the difference between the Expenses (% of total expenses) of Israel and Expenses (% of total expenses) of Netherlands?
Your response must be concise. -48.82. In the year 2012, what is the difference between the Expenses (% of total expenses) in Lithuania and Expenses (% of total expenses) in Netherlands?
Offer a very short reply. -16.8. What is the ratio of the Expenses (% of total expenses) of Israel in 2006 to that in 2007?
Keep it short and to the point. 1.01. What is the ratio of the Expenses (% of total expenses) in Lithuania in 2006 to that in 2007?
Make the answer very short. 0.97. What is the ratio of the Expenses (% of total expenses) of Lithuania in 2006 to that in 2008?
Provide a succinct answer. 0.93. What is the ratio of the Expenses (% of total expenses) in Upper middle income in 2006 to that in 2009?
Ensure brevity in your answer.  0.98. What is the ratio of the Expenses (% of total expenses) of Israel in 2006 to that in 2009?
Keep it short and to the point. 0.98. What is the ratio of the Expenses (% of total expenses) of Lithuania in 2006 to that in 2009?
Make the answer very short. 0.87. What is the ratio of the Expenses (% of total expenses) in Netherlands in 2006 to that in 2009?
Ensure brevity in your answer.  1.01. What is the ratio of the Expenses (% of total expenses) of Upper middle income in 2006 to that in 2010?
Give a very brief answer. 0.97. What is the ratio of the Expenses (% of total expenses) in Israel in 2006 to that in 2010?
Offer a very short reply. 0.97. What is the ratio of the Expenses (% of total expenses) in Lithuania in 2006 to that in 2010?
Offer a very short reply. 0.89. What is the ratio of the Expenses (% of total expenses) of Upper middle income in 2006 to that in 2011?
Offer a terse response. 0.91. What is the ratio of the Expenses (% of total expenses) in Israel in 2006 to that in 2011?
Your answer should be very brief. 0.95. What is the ratio of the Expenses (% of total expenses) of Lithuania in 2006 to that in 2011?
Provide a short and direct response. 0.91. What is the ratio of the Expenses (% of total expenses) of Netherlands in 2006 to that in 2011?
Offer a terse response. 0.98. What is the ratio of the Expenses (% of total expenses) in Upper middle income in 2006 to that in 2012?
Make the answer very short. 0.87. What is the ratio of the Expenses (% of total expenses) of Israel in 2006 to that in 2012?
Your response must be concise. 0.95. What is the ratio of the Expenses (% of total expenses) in Lithuania in 2006 to that in 2012?
Ensure brevity in your answer.  0.91. What is the ratio of the Expenses (% of total expenses) of Netherlands in 2006 to that in 2012?
Offer a terse response. 0.98. What is the ratio of the Expenses (% of total expenses) of Lithuania in 2007 to that in 2008?
Your answer should be compact. 0.96. What is the ratio of the Expenses (% of total expenses) of Upper middle income in 2007 to that in 2009?
Your answer should be compact. 0.97. What is the ratio of the Expenses (% of total expenses) of Israel in 2007 to that in 2009?
Your response must be concise. 0.97. What is the ratio of the Expenses (% of total expenses) of Lithuania in 2007 to that in 2009?
Keep it short and to the point. 0.9. What is the ratio of the Expenses (% of total expenses) in Upper middle income in 2007 to that in 2010?
Offer a very short reply. 0.96. What is the ratio of the Expenses (% of total expenses) in Israel in 2007 to that in 2010?
Provide a succinct answer. 0.97. What is the ratio of the Expenses (% of total expenses) in Lithuania in 2007 to that in 2010?
Offer a very short reply. 0.92. What is the ratio of the Expenses (% of total expenses) of Upper middle income in 2007 to that in 2011?
Make the answer very short. 0.9. What is the ratio of the Expenses (% of total expenses) of Israel in 2007 to that in 2011?
Your answer should be very brief. 0.94. What is the ratio of the Expenses (% of total expenses) in Lithuania in 2007 to that in 2011?
Ensure brevity in your answer.  0.94. What is the ratio of the Expenses (% of total expenses) of Netherlands in 2007 to that in 2011?
Offer a terse response. 0.99. What is the ratio of the Expenses (% of total expenses) in Upper middle income in 2007 to that in 2012?
Your answer should be very brief. 0.87. What is the ratio of the Expenses (% of total expenses) in Israel in 2007 to that in 2012?
Ensure brevity in your answer.  0.95. What is the ratio of the Expenses (% of total expenses) of Lithuania in 2007 to that in 2012?
Ensure brevity in your answer.  0.94. What is the ratio of the Expenses (% of total expenses) in Netherlands in 2007 to that in 2012?
Give a very brief answer. 0.98. What is the ratio of the Expenses (% of total expenses) of Upper middle income in 2008 to that in 2009?
Your answer should be very brief. 0.98. What is the ratio of the Expenses (% of total expenses) of Israel in 2008 to that in 2009?
Provide a short and direct response. 0.98. What is the ratio of the Expenses (% of total expenses) of Lithuania in 2008 to that in 2009?
Your response must be concise. 0.94. What is the ratio of the Expenses (% of total expenses) in Netherlands in 2008 to that in 2009?
Provide a succinct answer. 1.01. What is the ratio of the Expenses (% of total expenses) of Upper middle income in 2008 to that in 2010?
Provide a short and direct response. 0.97. What is the ratio of the Expenses (% of total expenses) in Israel in 2008 to that in 2010?
Provide a succinct answer. 0.98. What is the ratio of the Expenses (% of total expenses) in Lithuania in 2008 to that in 2010?
Offer a very short reply. 0.96. What is the ratio of the Expenses (% of total expenses) of Netherlands in 2008 to that in 2010?
Offer a terse response. 0.99. What is the ratio of the Expenses (% of total expenses) of Upper middle income in 2008 to that in 2011?
Your answer should be compact. 0.91. What is the ratio of the Expenses (% of total expenses) in Israel in 2008 to that in 2011?
Provide a succinct answer. 0.95. What is the ratio of the Expenses (% of total expenses) in Lithuania in 2008 to that in 2011?
Provide a succinct answer. 0.98. What is the ratio of the Expenses (% of total expenses) in Upper middle income in 2008 to that in 2012?
Ensure brevity in your answer.  0.87. What is the ratio of the Expenses (% of total expenses) of Israel in 2008 to that in 2012?
Provide a succinct answer. 0.96. What is the ratio of the Expenses (% of total expenses) in Lithuania in 2008 to that in 2012?
Provide a short and direct response. 0.98. What is the ratio of the Expenses (% of total expenses) in Netherlands in 2008 to that in 2012?
Your answer should be very brief. 0.98. What is the ratio of the Expenses (% of total expenses) of Upper middle income in 2009 to that in 2010?
Offer a very short reply. 0.99. What is the ratio of the Expenses (% of total expenses) in Lithuania in 2009 to that in 2010?
Provide a succinct answer. 1.02. What is the ratio of the Expenses (% of total expenses) in Netherlands in 2009 to that in 2010?
Your response must be concise. 0.98. What is the ratio of the Expenses (% of total expenses) in Upper middle income in 2009 to that in 2011?
Offer a very short reply. 0.93. What is the ratio of the Expenses (% of total expenses) in Israel in 2009 to that in 2011?
Make the answer very short. 0.97. What is the ratio of the Expenses (% of total expenses) in Lithuania in 2009 to that in 2011?
Give a very brief answer. 1.04. What is the ratio of the Expenses (% of total expenses) of Netherlands in 2009 to that in 2011?
Ensure brevity in your answer.  0.98. What is the ratio of the Expenses (% of total expenses) in Israel in 2009 to that in 2012?
Give a very brief answer. 0.98. What is the ratio of the Expenses (% of total expenses) in Lithuania in 2009 to that in 2012?
Ensure brevity in your answer.  1.04. What is the ratio of the Expenses (% of total expenses) of Netherlands in 2009 to that in 2012?
Your answer should be compact. 0.98. What is the ratio of the Expenses (% of total expenses) in Upper middle income in 2010 to that in 2011?
Your answer should be compact. 0.94. What is the ratio of the Expenses (% of total expenses) of Israel in 2010 to that in 2011?
Keep it short and to the point. 0.98. What is the ratio of the Expenses (% of total expenses) in Lithuania in 2010 to that in 2011?
Your answer should be very brief. 1.03. What is the ratio of the Expenses (% of total expenses) of Netherlands in 2010 to that in 2011?
Provide a succinct answer. 0.99. What is the ratio of the Expenses (% of total expenses) in Upper middle income in 2010 to that in 2012?
Provide a short and direct response. 0.9. What is the ratio of the Expenses (% of total expenses) in Israel in 2010 to that in 2012?
Your answer should be compact. 0.98. What is the ratio of the Expenses (% of total expenses) in Lithuania in 2010 to that in 2012?
Your answer should be compact. 1.03. What is the ratio of the Expenses (% of total expenses) in Netherlands in 2010 to that in 2012?
Offer a terse response. 0.99. What is the ratio of the Expenses (% of total expenses) in Upper middle income in 2011 to that in 2012?
Your answer should be very brief. 0.96. What is the ratio of the Expenses (% of total expenses) in Israel in 2011 to that in 2012?
Your response must be concise. 1. What is the ratio of the Expenses (% of total expenses) of Lithuania in 2011 to that in 2012?
Your response must be concise. 1. What is the difference between the highest and the second highest Expenses (% of total expenses) of Upper middle income?
Make the answer very short. 1.89. What is the difference between the highest and the second highest Expenses (% of total expenses) in Israel?
Provide a short and direct response. 0.12. What is the difference between the highest and the second highest Expenses (% of total expenses) in Lithuania?
Provide a short and direct response. 0.98. What is the difference between the highest and the second highest Expenses (% of total expenses) of Netherlands?
Make the answer very short. 0.17. What is the difference between the highest and the lowest Expenses (% of total expenses) of Upper middle income?
Give a very brief answer. 6.23. What is the difference between the highest and the lowest Expenses (% of total expenses) of Israel?
Give a very brief answer. 1.68. What is the difference between the highest and the lowest Expenses (% of total expenses) in Lithuania?
Ensure brevity in your answer.  8.22. What is the difference between the highest and the lowest Expenses (% of total expenses) of Netherlands?
Keep it short and to the point. 1.84. 